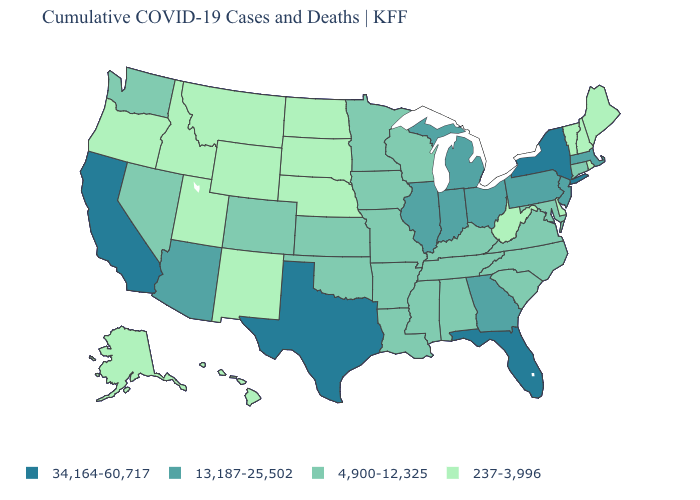How many symbols are there in the legend?
Keep it brief. 4. What is the lowest value in states that border North Carolina?
Quick response, please. 4,900-12,325. What is the lowest value in states that border Arkansas?
Write a very short answer. 4,900-12,325. How many symbols are there in the legend?
Keep it brief. 4. What is the value of Oklahoma?
Give a very brief answer. 4,900-12,325. Does Nevada have the highest value in the West?
Give a very brief answer. No. Among the states that border New York , does New Jersey have the highest value?
Give a very brief answer. Yes. Which states hav the highest value in the West?
Write a very short answer. California. Name the states that have a value in the range 237-3,996?
Concise answer only. Alaska, Delaware, Hawaii, Idaho, Maine, Montana, Nebraska, New Hampshire, New Mexico, North Dakota, Oregon, Rhode Island, South Dakota, Utah, Vermont, West Virginia, Wyoming. Which states have the lowest value in the Northeast?
Short answer required. Maine, New Hampshire, Rhode Island, Vermont. What is the highest value in the USA?
Short answer required. 34,164-60,717. Does California have the highest value in the West?
Keep it brief. Yes. Does the first symbol in the legend represent the smallest category?
Quick response, please. No. Name the states that have a value in the range 34,164-60,717?
Concise answer only. California, Florida, New York, Texas. 